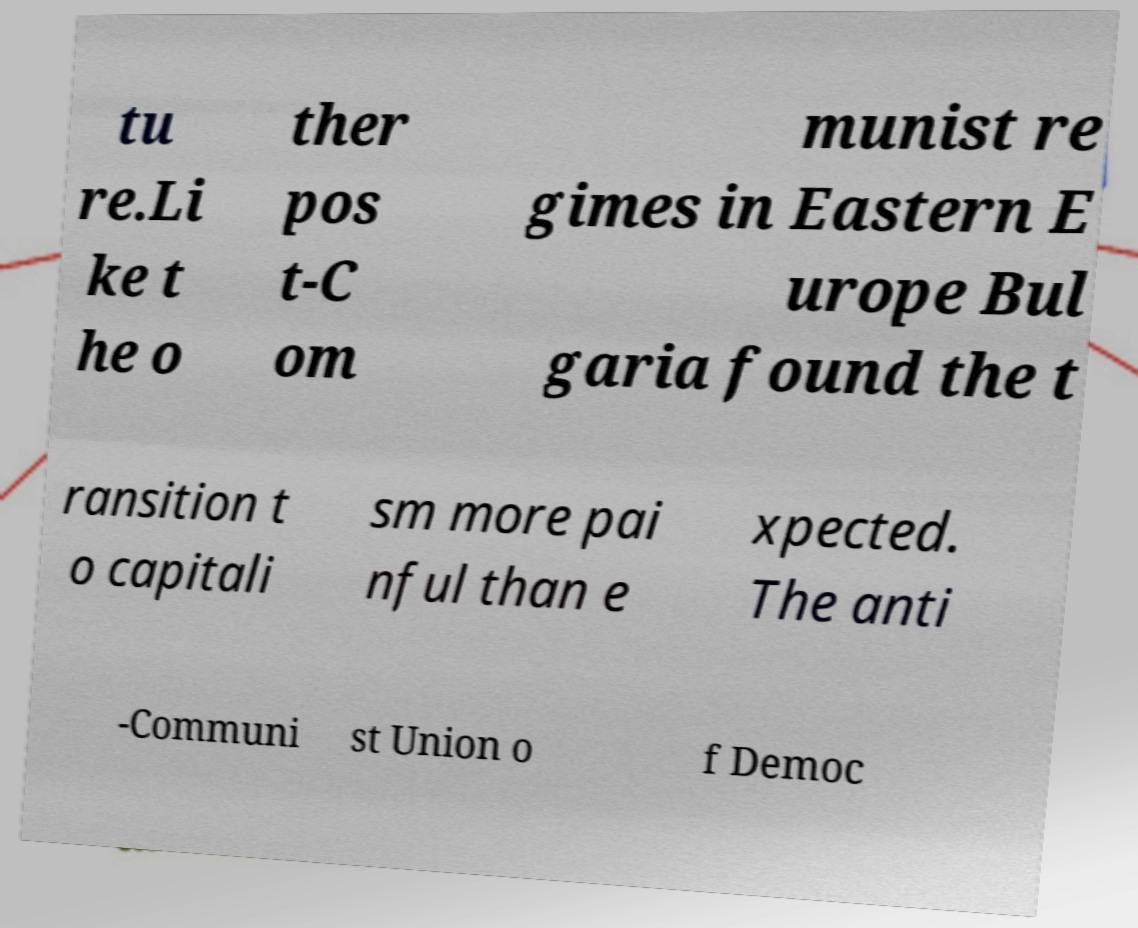For documentation purposes, I need the text within this image transcribed. Could you provide that? tu re.Li ke t he o ther pos t-C om munist re gimes in Eastern E urope Bul garia found the t ransition t o capitali sm more pai nful than e xpected. The anti -Communi st Union o f Democ 